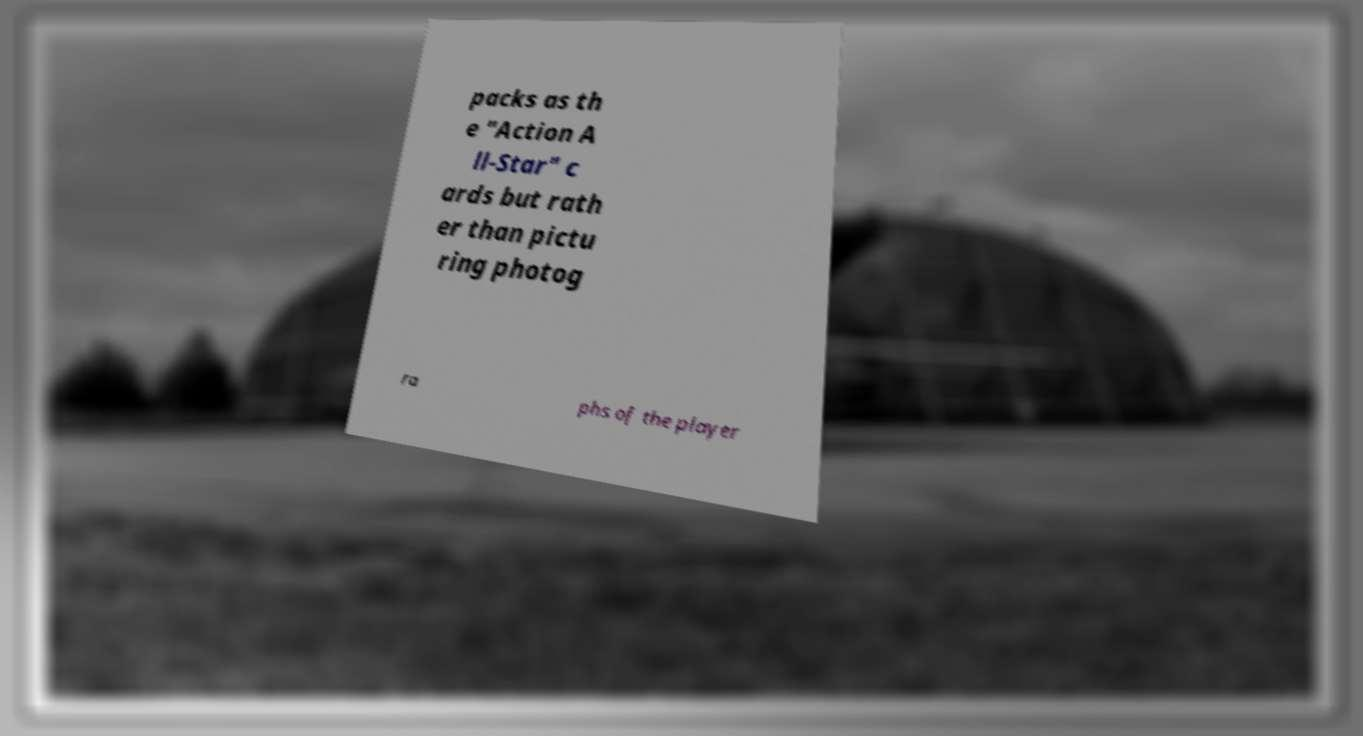Can you accurately transcribe the text from the provided image for me? packs as th e "Action A ll-Star" c ards but rath er than pictu ring photog ra phs of the player 